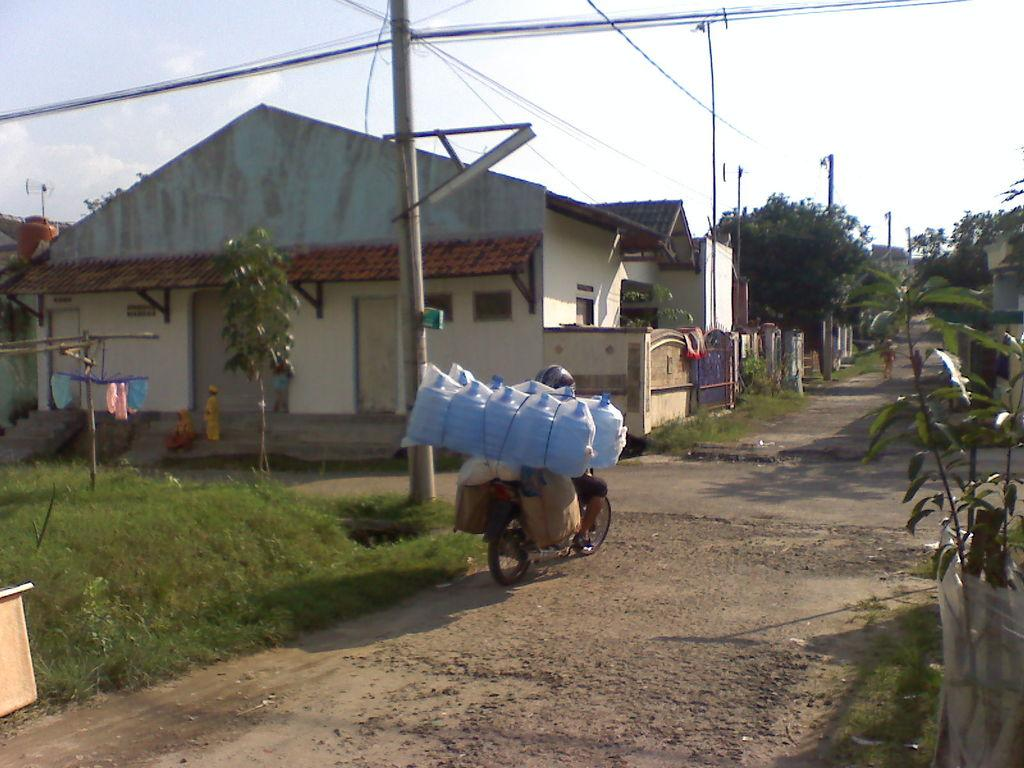What is the man in the image doing? The man is riding a scooter in the image. What safety precaution is the man taking while riding the scooter? The man is wearing a helmet. Where is the scooter located? The scooter is on a road. What can be seen in the background of the image? There is grassland, trees, houses, a pole, and the sky visible in the background. Can you describe the plant in the bottom right corner of the image? Yes, there is a plant in the bottom right corner of the image. What type of lace can be seen on the scooter in the image? There is no lace present on the scooter in the image. What sound can be heard from the cannon in the image? There is no cannon present in the image, so no sound can be heard from it. 